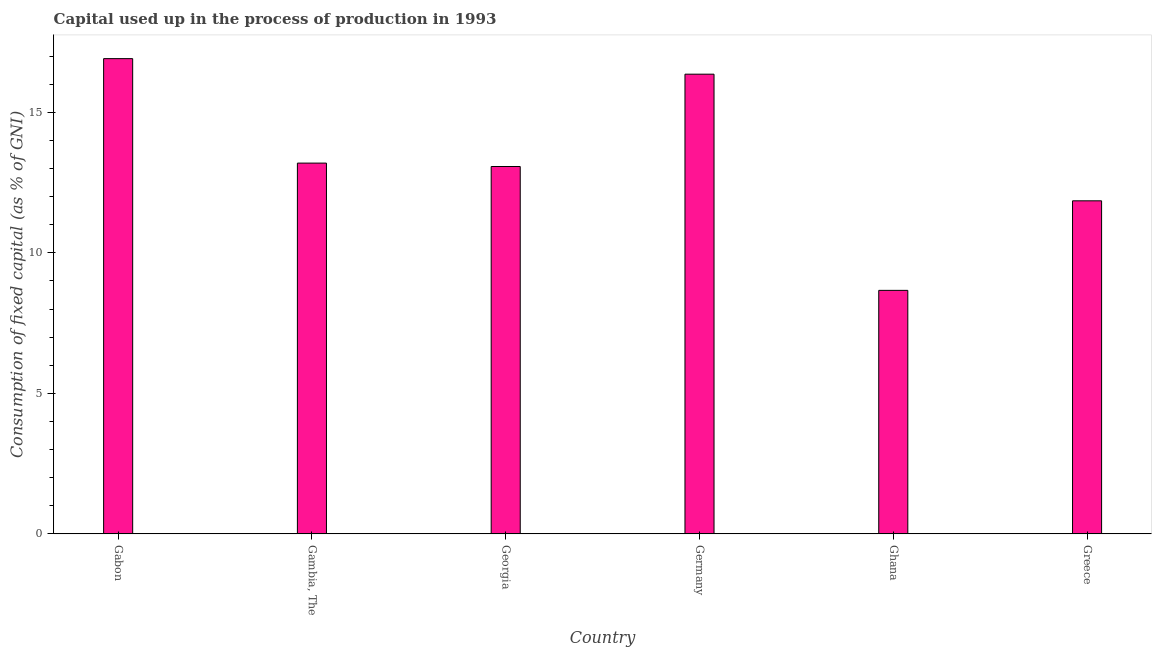What is the title of the graph?
Your response must be concise. Capital used up in the process of production in 1993. What is the label or title of the X-axis?
Keep it short and to the point. Country. What is the label or title of the Y-axis?
Ensure brevity in your answer.  Consumption of fixed capital (as % of GNI). What is the consumption of fixed capital in Gambia, The?
Give a very brief answer. 13.19. Across all countries, what is the maximum consumption of fixed capital?
Ensure brevity in your answer.  16.91. Across all countries, what is the minimum consumption of fixed capital?
Make the answer very short. 8.66. In which country was the consumption of fixed capital maximum?
Your answer should be compact. Gabon. In which country was the consumption of fixed capital minimum?
Your answer should be compact. Ghana. What is the sum of the consumption of fixed capital?
Keep it short and to the point. 80.05. What is the difference between the consumption of fixed capital in Gabon and Ghana?
Give a very brief answer. 8.25. What is the average consumption of fixed capital per country?
Your answer should be compact. 13.34. What is the median consumption of fixed capital?
Make the answer very short. 13.13. In how many countries, is the consumption of fixed capital greater than 15 %?
Make the answer very short. 2. What is the ratio of the consumption of fixed capital in Gabon to that in Ghana?
Ensure brevity in your answer.  1.95. What is the difference between the highest and the second highest consumption of fixed capital?
Provide a short and direct response. 0.55. Is the sum of the consumption of fixed capital in Germany and Ghana greater than the maximum consumption of fixed capital across all countries?
Make the answer very short. Yes. What is the difference between the highest and the lowest consumption of fixed capital?
Provide a succinct answer. 8.25. What is the difference between two consecutive major ticks on the Y-axis?
Ensure brevity in your answer.  5. Are the values on the major ticks of Y-axis written in scientific E-notation?
Make the answer very short. No. What is the Consumption of fixed capital (as % of GNI) in Gabon?
Offer a terse response. 16.91. What is the Consumption of fixed capital (as % of GNI) of Gambia, The?
Offer a very short reply. 13.19. What is the Consumption of fixed capital (as % of GNI) in Georgia?
Your response must be concise. 13.07. What is the Consumption of fixed capital (as % of GNI) of Germany?
Keep it short and to the point. 16.36. What is the Consumption of fixed capital (as % of GNI) of Ghana?
Your response must be concise. 8.66. What is the Consumption of fixed capital (as % of GNI) of Greece?
Make the answer very short. 11.85. What is the difference between the Consumption of fixed capital (as % of GNI) in Gabon and Gambia, The?
Ensure brevity in your answer.  3.72. What is the difference between the Consumption of fixed capital (as % of GNI) in Gabon and Georgia?
Provide a succinct answer. 3.84. What is the difference between the Consumption of fixed capital (as % of GNI) in Gabon and Germany?
Make the answer very short. 0.55. What is the difference between the Consumption of fixed capital (as % of GNI) in Gabon and Ghana?
Give a very brief answer. 8.25. What is the difference between the Consumption of fixed capital (as % of GNI) in Gabon and Greece?
Your answer should be compact. 5.06. What is the difference between the Consumption of fixed capital (as % of GNI) in Gambia, The and Georgia?
Make the answer very short. 0.12. What is the difference between the Consumption of fixed capital (as % of GNI) in Gambia, The and Germany?
Your answer should be compact. -3.16. What is the difference between the Consumption of fixed capital (as % of GNI) in Gambia, The and Ghana?
Your answer should be very brief. 4.53. What is the difference between the Consumption of fixed capital (as % of GNI) in Gambia, The and Greece?
Your answer should be compact. 1.34. What is the difference between the Consumption of fixed capital (as % of GNI) in Georgia and Germany?
Offer a terse response. -3.29. What is the difference between the Consumption of fixed capital (as % of GNI) in Georgia and Ghana?
Your answer should be compact. 4.41. What is the difference between the Consumption of fixed capital (as % of GNI) in Georgia and Greece?
Provide a succinct answer. 1.22. What is the difference between the Consumption of fixed capital (as % of GNI) in Germany and Ghana?
Provide a succinct answer. 7.69. What is the difference between the Consumption of fixed capital (as % of GNI) in Germany and Greece?
Offer a terse response. 4.51. What is the difference between the Consumption of fixed capital (as % of GNI) in Ghana and Greece?
Give a very brief answer. -3.19. What is the ratio of the Consumption of fixed capital (as % of GNI) in Gabon to that in Gambia, The?
Provide a short and direct response. 1.28. What is the ratio of the Consumption of fixed capital (as % of GNI) in Gabon to that in Georgia?
Offer a very short reply. 1.29. What is the ratio of the Consumption of fixed capital (as % of GNI) in Gabon to that in Germany?
Ensure brevity in your answer.  1.03. What is the ratio of the Consumption of fixed capital (as % of GNI) in Gabon to that in Ghana?
Give a very brief answer. 1.95. What is the ratio of the Consumption of fixed capital (as % of GNI) in Gabon to that in Greece?
Keep it short and to the point. 1.43. What is the ratio of the Consumption of fixed capital (as % of GNI) in Gambia, The to that in Germany?
Provide a short and direct response. 0.81. What is the ratio of the Consumption of fixed capital (as % of GNI) in Gambia, The to that in Ghana?
Offer a terse response. 1.52. What is the ratio of the Consumption of fixed capital (as % of GNI) in Gambia, The to that in Greece?
Keep it short and to the point. 1.11. What is the ratio of the Consumption of fixed capital (as % of GNI) in Georgia to that in Germany?
Offer a very short reply. 0.8. What is the ratio of the Consumption of fixed capital (as % of GNI) in Georgia to that in Ghana?
Offer a very short reply. 1.51. What is the ratio of the Consumption of fixed capital (as % of GNI) in Georgia to that in Greece?
Provide a succinct answer. 1.1. What is the ratio of the Consumption of fixed capital (as % of GNI) in Germany to that in Ghana?
Make the answer very short. 1.89. What is the ratio of the Consumption of fixed capital (as % of GNI) in Germany to that in Greece?
Offer a very short reply. 1.38. What is the ratio of the Consumption of fixed capital (as % of GNI) in Ghana to that in Greece?
Your response must be concise. 0.73. 